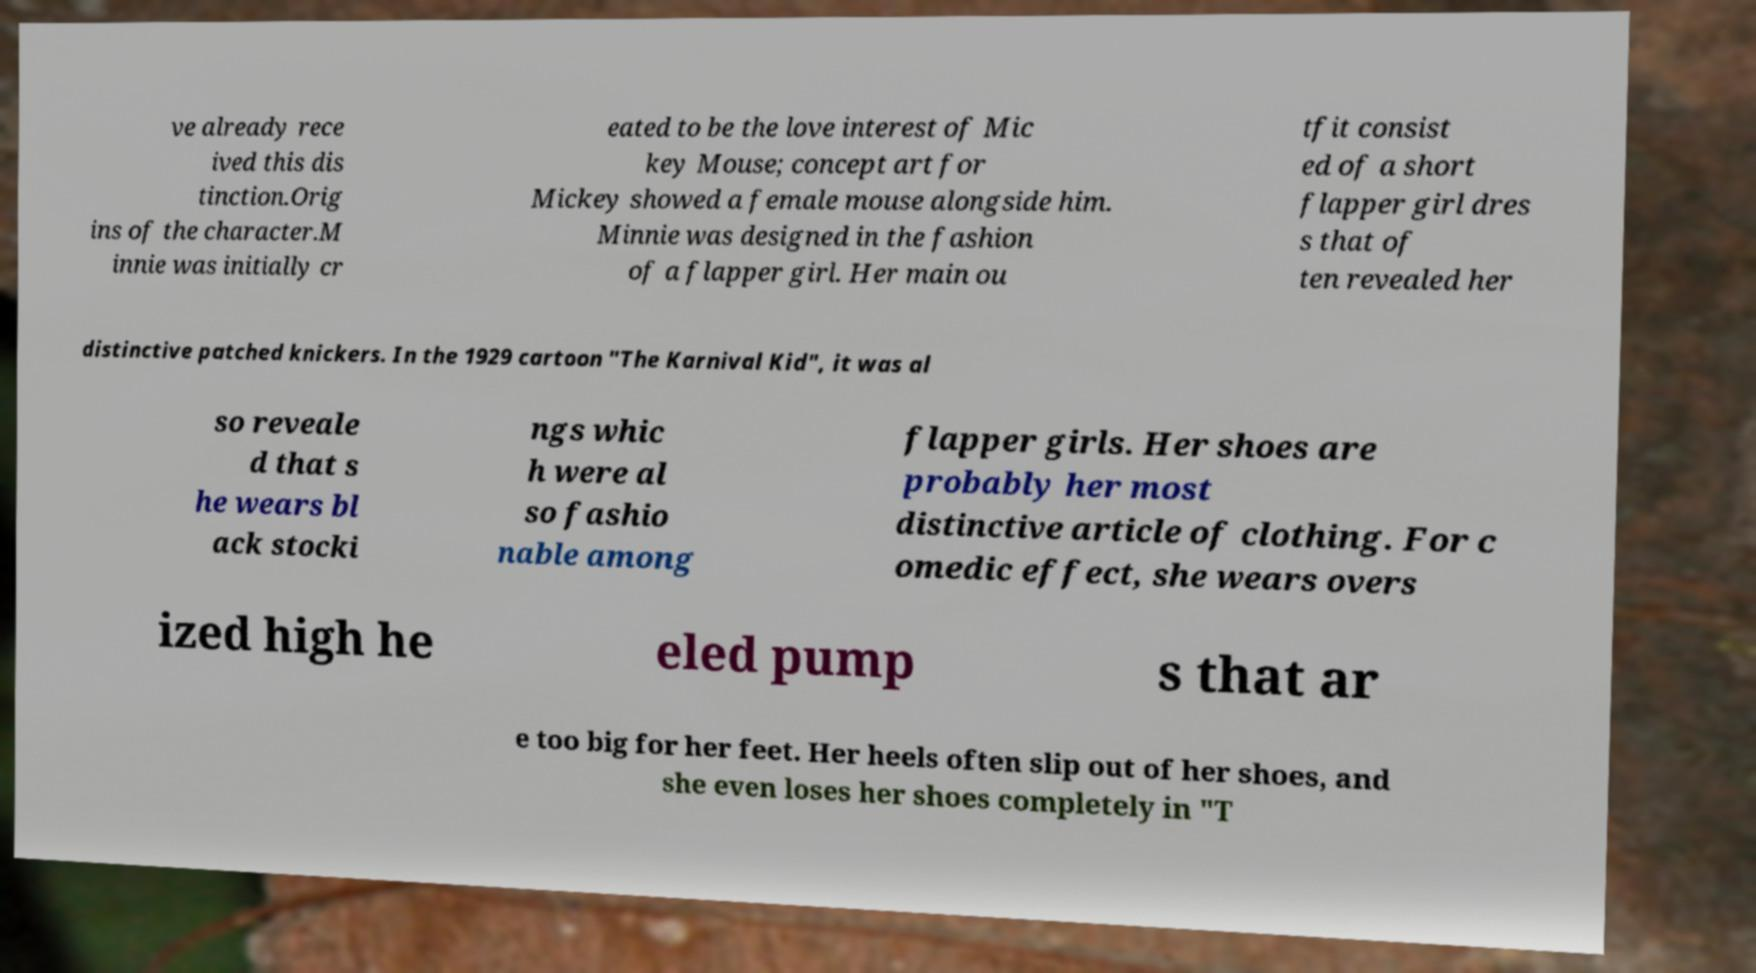Could you assist in decoding the text presented in this image and type it out clearly? ve already rece ived this dis tinction.Orig ins of the character.M innie was initially cr eated to be the love interest of Mic key Mouse; concept art for Mickey showed a female mouse alongside him. Minnie was designed in the fashion of a flapper girl. Her main ou tfit consist ed of a short flapper girl dres s that of ten revealed her distinctive patched knickers. In the 1929 cartoon "The Karnival Kid", it was al so reveale d that s he wears bl ack stocki ngs whic h were al so fashio nable among flapper girls. Her shoes are probably her most distinctive article of clothing. For c omedic effect, she wears overs ized high he eled pump s that ar e too big for her feet. Her heels often slip out of her shoes, and she even loses her shoes completely in "T 